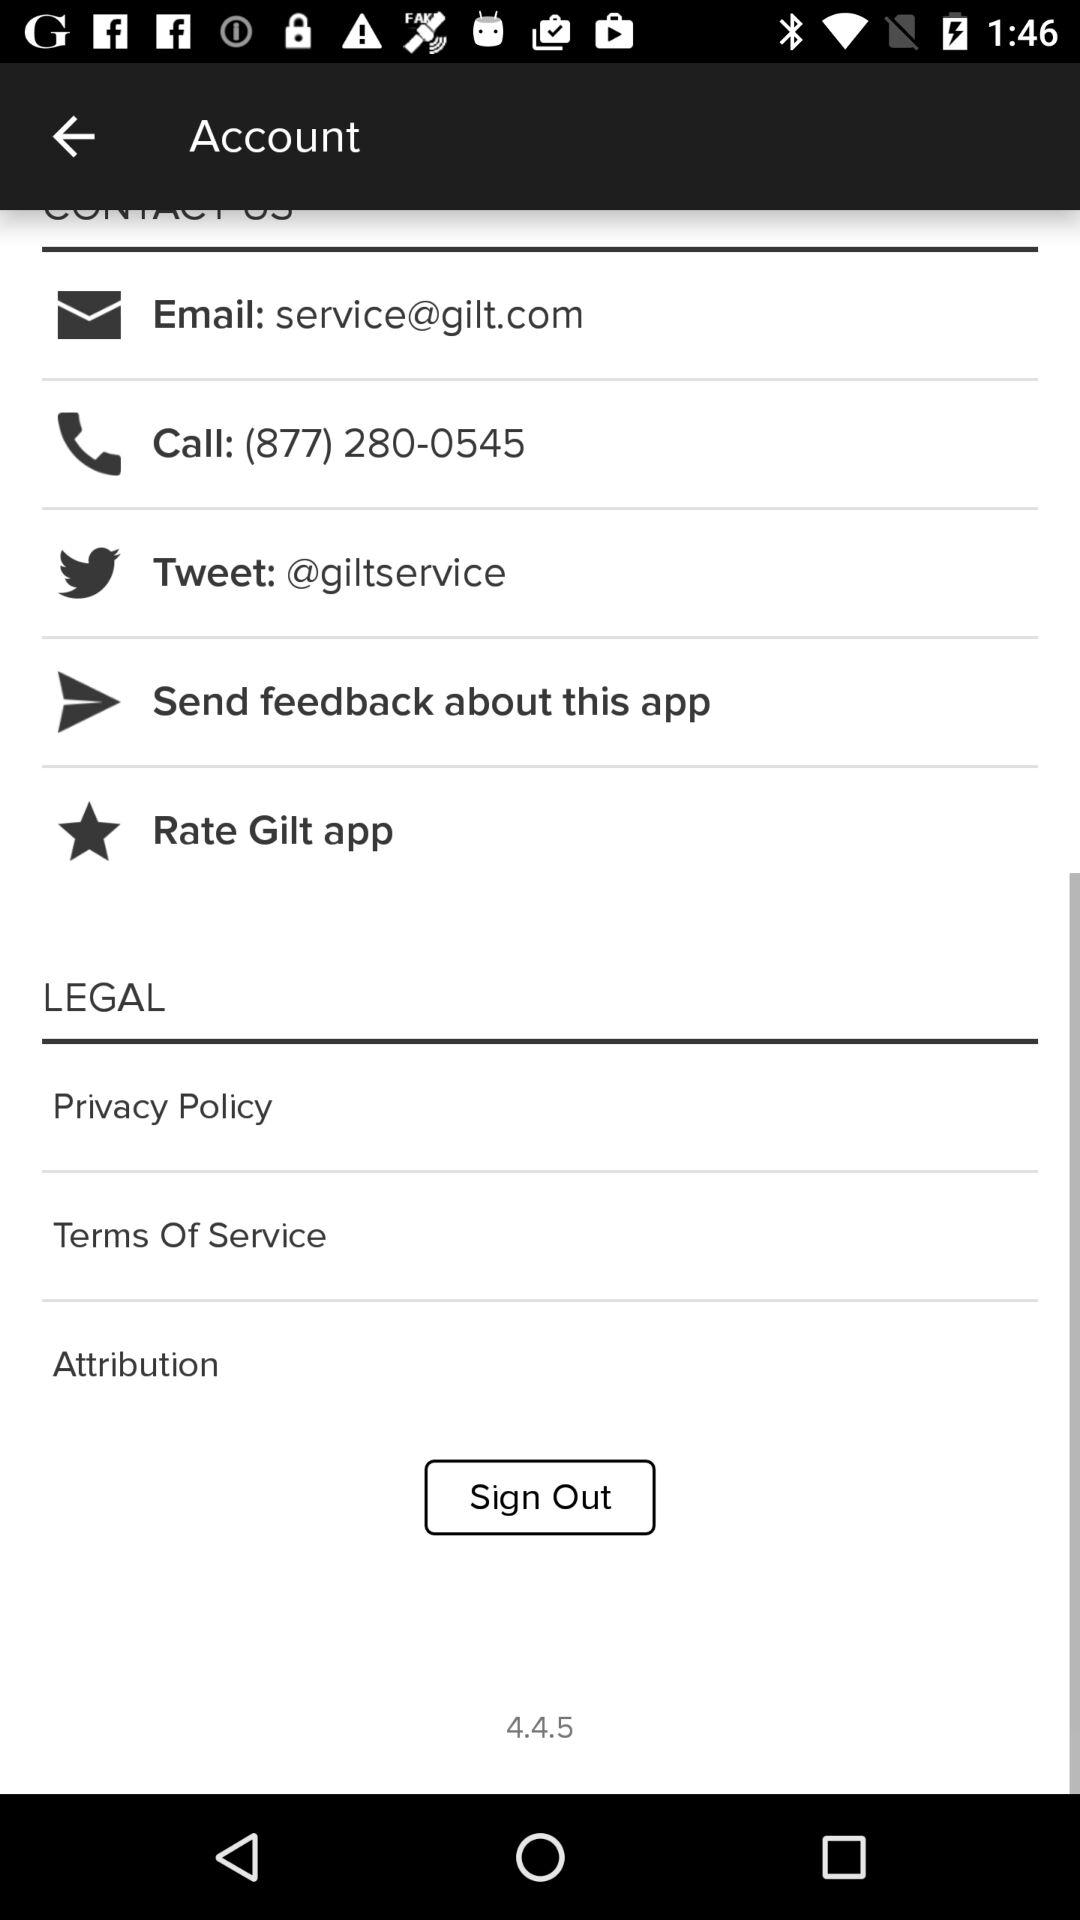What is the provided email address? The provided email address is service@gilt.com. 